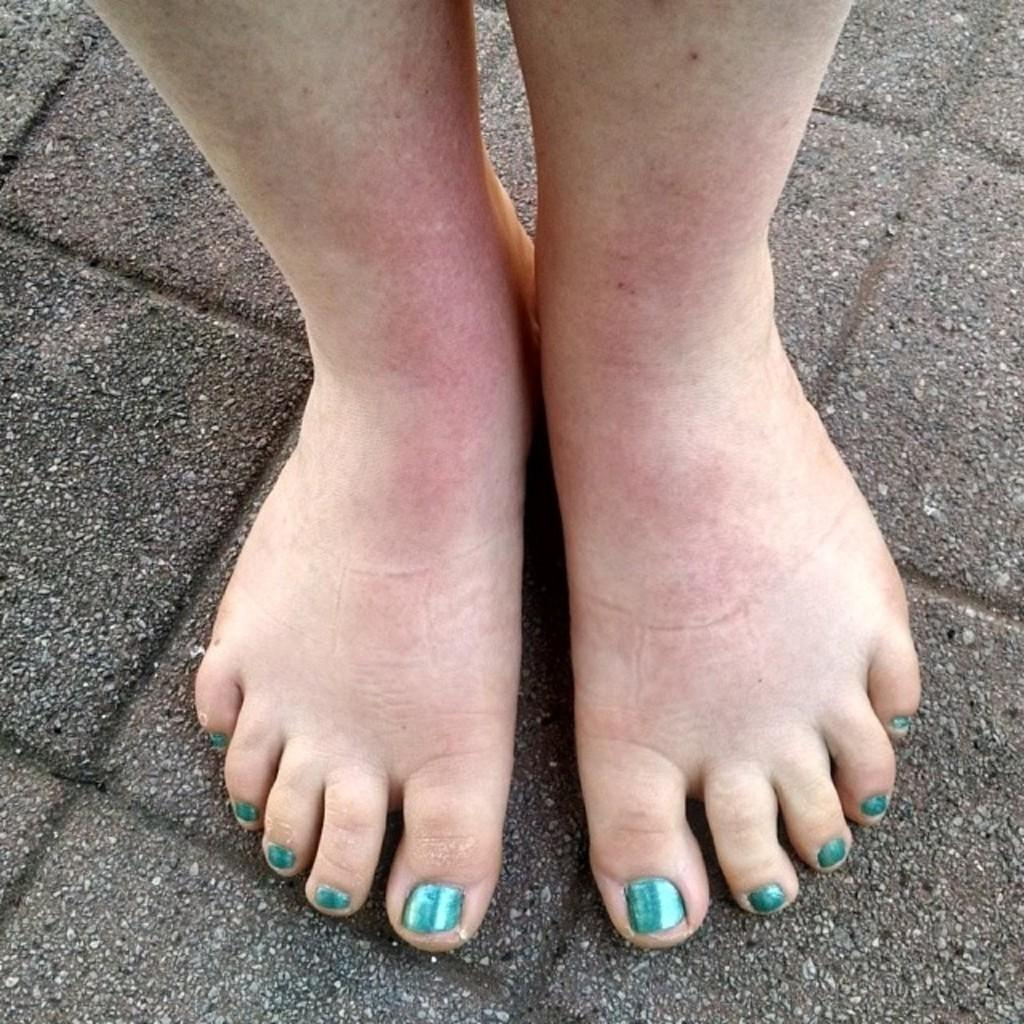What is the main subject in the center of the image? There are human legs in the center of the image. What can be observed about the nails on the human legs? The nails on the human legs have green color nail paint. What type of coast can be seen in the background of the image? There is no coast visible in the image; it only features human legs with green nail paint. 